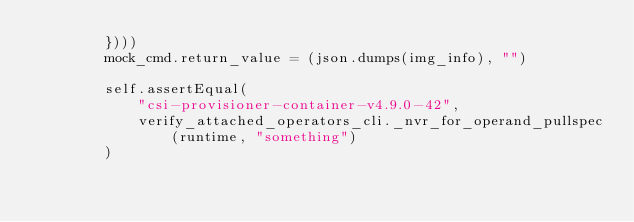<code> <loc_0><loc_0><loc_500><loc_500><_Python_>        })))
        mock_cmd.return_value = (json.dumps(img_info), "")

        self.assertEqual(
            "csi-provisioner-container-v4.9.0-42",
            verify_attached_operators_cli._nvr_for_operand_pullspec(runtime, "something")
        )
</code> 